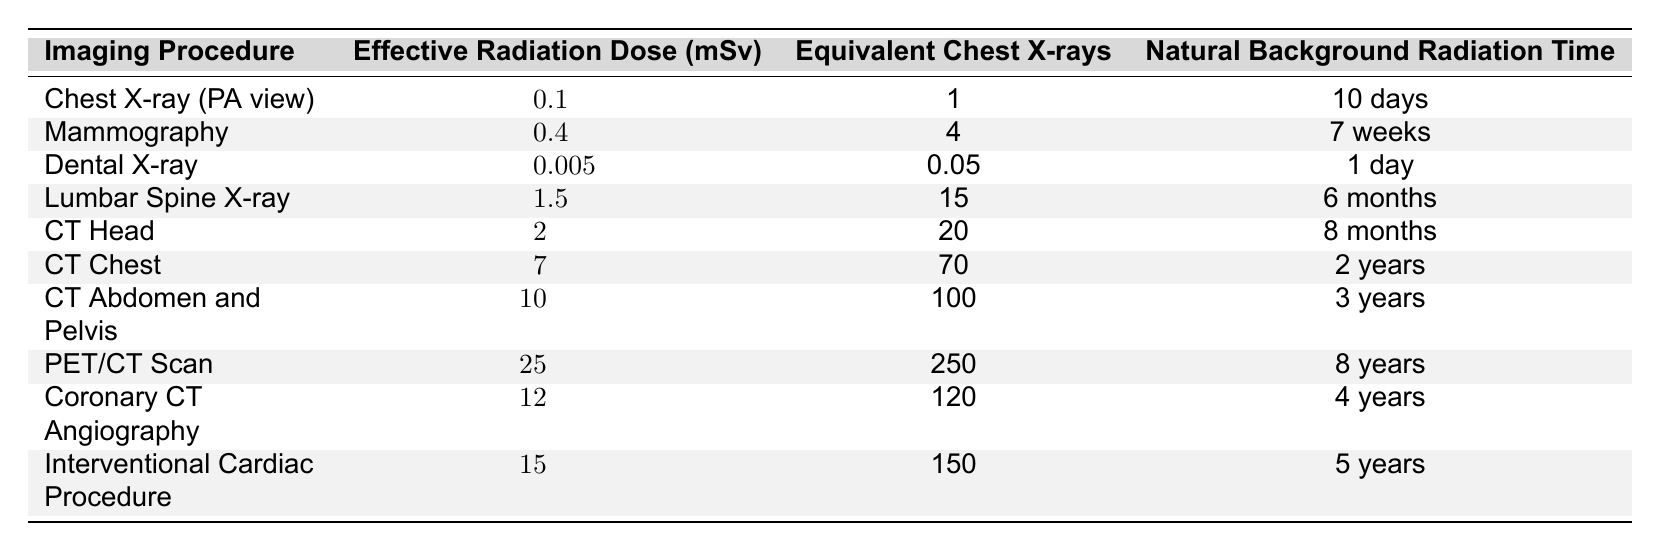What is the effective radiation dose for a Dental X-ray? The table lists the effective radiation dose for a Dental X-ray as 0.005 mSv.
Answer: 0.005 mSv Which procedure exposes a patient to the highest level of radiation? According to the table, the PET/CT Scan has the highest effective radiation dose at 25 mSv.
Answer: PET/CT Scan How many chest X-rays is the effective radiation dose of a CT Chest equivalent to? The table states that the effective radiation dose of a CT Chest is equivalent to 70 chest X-rays.
Answer: 70 What is the natural background radiation time for a Mammography? The table shows that the natural background radiation time for a Mammography is 7 weeks.
Answer: 7 weeks Is the effective radiation dose for a Lumbar Spine X-ray greater than that of a CT Head? The Lumbar Spine X-ray has an effective radiation dose of 1.5 mSv, while the CT Head has a dose of 2 mSv. Since 1.5 is less than 2, the statement is false.
Answer: No What is the total effective radiation dose of a CT Abdomen and Pelvis and a Coronary CT Angiography? The effective radiation dose for a CT Abdomen and Pelvis is 10 mSv, and for a Coronary CT Angiography, it is 12 mSv. Adding these together gives 10 + 12 = 22 mSv.
Answer: 22 mSv What percentage of the effective radiation dose from a PET/CT Scan is comparatively lower than that from a CT Chest? The effective radiation dose of a CT Chest is 7 mSv, and a PET/CT Scan is 25 mSv. The percentage difference is calculated as (7/25) * 100 = 28%.
Answer: 28% Among the imaging procedures, which one has a natural background radiation time of less than a month? Based on the table, the Dental X-ray has a natural background radiation time of 1 day, which is less than a month.
Answer: Dental X-ray Which imaging procedure requires the longest natural background radiation recovery time? The table indicates that the PET/CT Scan requires the longest recovery time of 8 years.
Answer: PET/CT Scan What is the average effective radiation dose for the three X-ray procedures listed: Chest X-ray, Mammography, and Lumbar Spine X-ray? The effective doses are 0.1 mSv (Chest X-ray), 0.4 mSv (Mammography), and 1.5 mSv (Lumbar Spine X-ray). The total dose is 0.1 + 0.4 + 1.5 = 2 mSv. Dividing by 3 gives an average of 2/3 = 0.67 mSv.
Answer: 0.67 mSv 